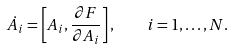<formula> <loc_0><loc_0><loc_500><loc_500>\dot { A _ { i } } = \left [ A _ { i } , \frac { \partial F } { \partial A _ { i } } \right ] , \quad i = 1 , \dots , N .</formula> 